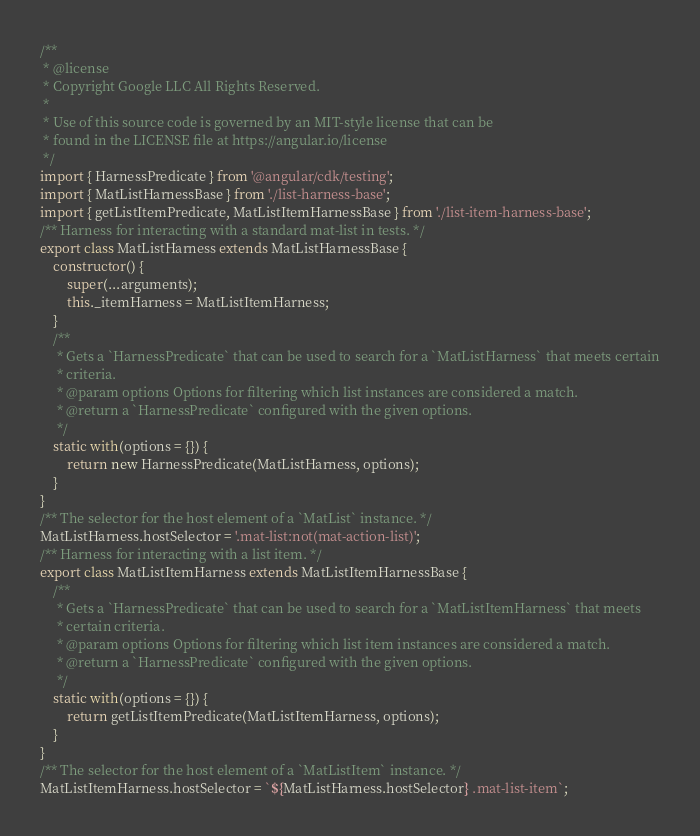<code> <loc_0><loc_0><loc_500><loc_500><_JavaScript_>/**
 * @license
 * Copyright Google LLC All Rights Reserved.
 *
 * Use of this source code is governed by an MIT-style license that can be
 * found in the LICENSE file at https://angular.io/license
 */
import { HarnessPredicate } from '@angular/cdk/testing';
import { MatListHarnessBase } from './list-harness-base';
import { getListItemPredicate, MatListItemHarnessBase } from './list-item-harness-base';
/** Harness for interacting with a standard mat-list in tests. */
export class MatListHarness extends MatListHarnessBase {
    constructor() {
        super(...arguments);
        this._itemHarness = MatListItemHarness;
    }
    /**
     * Gets a `HarnessPredicate` that can be used to search for a `MatListHarness` that meets certain
     * criteria.
     * @param options Options for filtering which list instances are considered a match.
     * @return a `HarnessPredicate` configured with the given options.
     */
    static with(options = {}) {
        return new HarnessPredicate(MatListHarness, options);
    }
}
/** The selector for the host element of a `MatList` instance. */
MatListHarness.hostSelector = '.mat-list:not(mat-action-list)';
/** Harness for interacting with a list item. */
export class MatListItemHarness extends MatListItemHarnessBase {
    /**
     * Gets a `HarnessPredicate` that can be used to search for a `MatListItemHarness` that meets
     * certain criteria.
     * @param options Options for filtering which list item instances are considered a match.
     * @return a `HarnessPredicate` configured with the given options.
     */
    static with(options = {}) {
        return getListItemPredicate(MatListItemHarness, options);
    }
}
/** The selector for the host element of a `MatListItem` instance. */
MatListItemHarness.hostSelector = `${MatListHarness.hostSelector} .mat-list-item`;</code> 